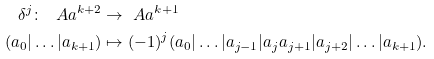<formula> <loc_0><loc_0><loc_500><loc_500>\delta ^ { j } \colon \ A a ^ { k + 2 } & \to \ A a ^ { k + 1 } \\ ( a _ { 0 } | \dots | a _ { k + 1 } ) & \mapsto ( - 1 ) ^ { j } ( a _ { 0 } | \dots | a _ { j - 1 } | a _ { j } a _ { j + 1 } | a _ { j + 2 } | \dots | a _ { k + 1 } ) .</formula> 